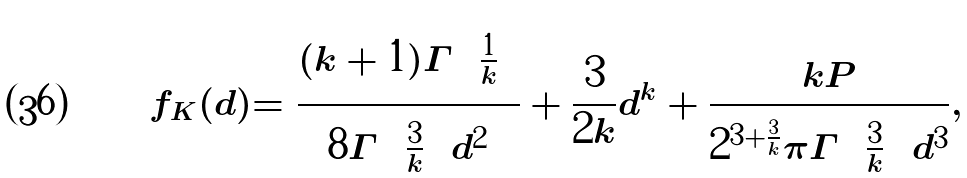Convert formula to latex. <formula><loc_0><loc_0><loc_500><loc_500>f _ { K } ( d ) = \frac { ( k + 1 ) \Gamma \left ( \frac { 1 } { k } \right ) } { 8 \Gamma \left ( \frac { 3 } { k } \right ) d ^ { 2 } } + \frac { 3 } { 2 k } d ^ { k } + \frac { k P } { 2 ^ { 3 + \frac { 3 } { k } } \pi \Gamma \left ( \frac { 3 } { k } \right ) d ^ { 3 } } ,</formula> 